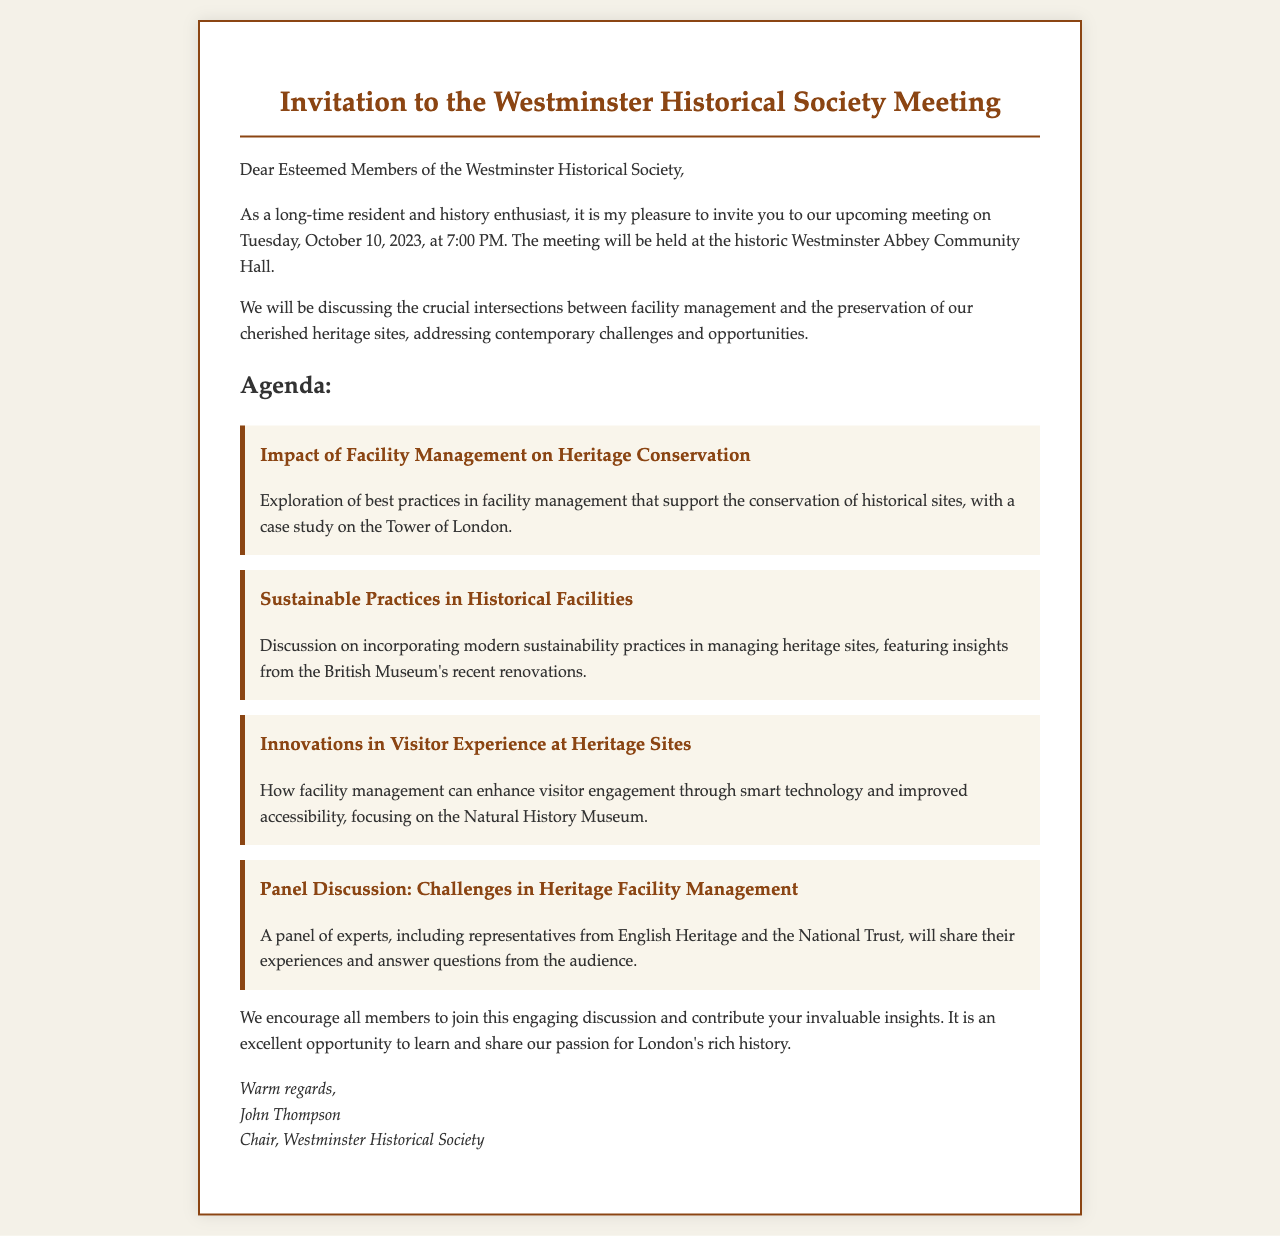What is the date of the meeting? The document states that the meeting will be held on Tuesday, October 10, 2023.
Answer: October 10, 2023 Where will the meeting take place? According to the document, the meeting will be held at the historic Westminster Abbey Community Hall.
Answer: Westminster Abbey Community Hall Who is the chair of the Westminster Historical Society? The letter indicates that John Thompson is the chair of the society.
Answer: John Thompson What is one of the agenda items related to sustainability? The agenda item discusses incorporating modern sustainability practices in managing heritage sites.
Answer: Sustainable Practices in Historical Facilities Which historical site is mentioned in relation to a case study? The document mentions the Tower of London as a case study in facility management practices.
Answer: Tower of London What type of discussion will the panel include? The letter specifies that there will be a panel discussion on challenges in heritage facility management.
Answer: Challenges in Heritage Facility Management How many agenda items are listed in the document? The document lists four specific agenda items for discussion during the meeting.
Answer: Four What is emphasized as a benefit of joining the meeting? The document encourages members to contribute insights and learn about preserving London's rich history.
Answer: Engage in discussion and share insights 